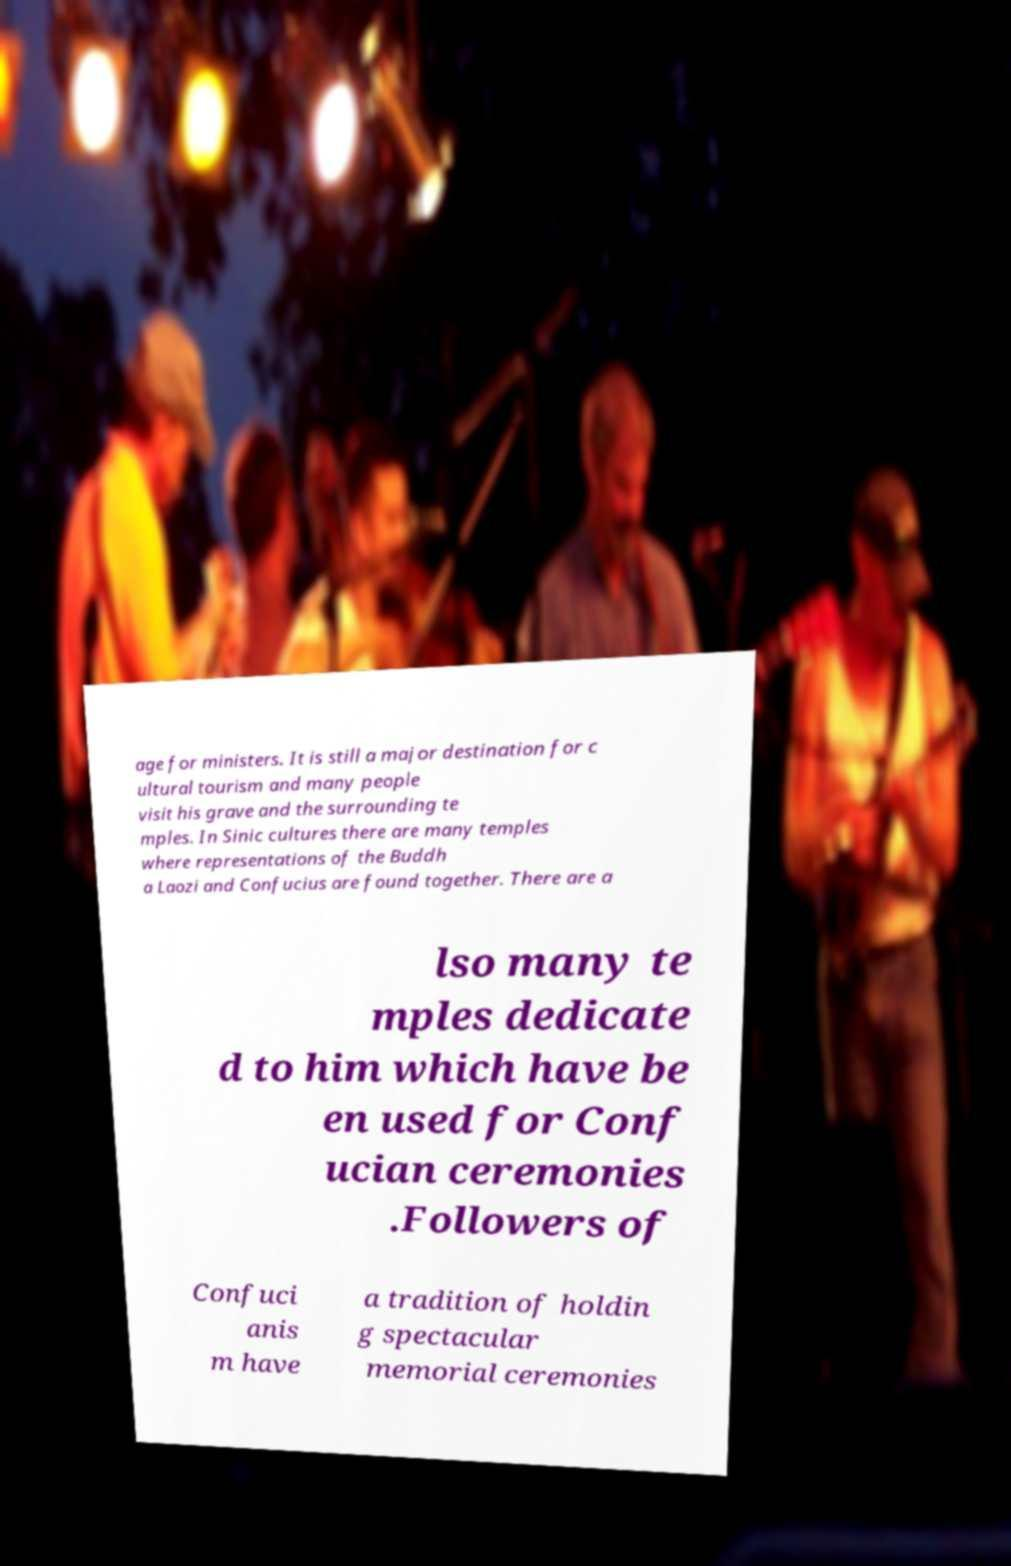Can you accurately transcribe the text from the provided image for me? age for ministers. It is still a major destination for c ultural tourism and many people visit his grave and the surrounding te mples. In Sinic cultures there are many temples where representations of the Buddh a Laozi and Confucius are found together. There are a lso many te mples dedicate d to him which have be en used for Conf ucian ceremonies .Followers of Confuci anis m have a tradition of holdin g spectacular memorial ceremonies 